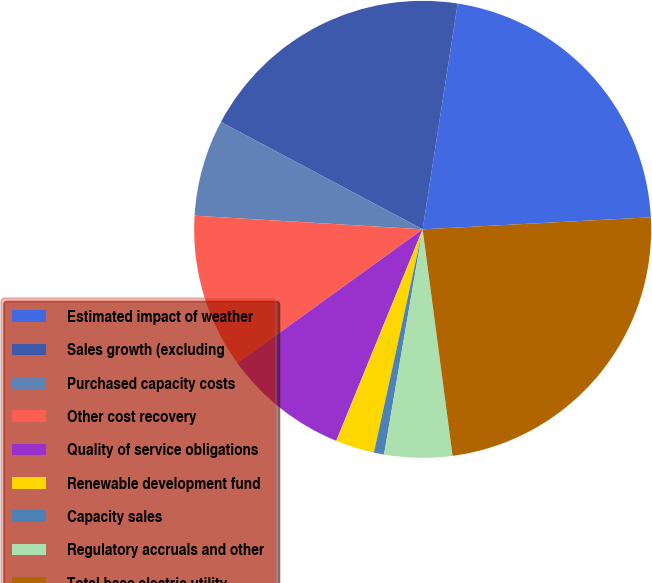<chart> <loc_0><loc_0><loc_500><loc_500><pie_chart><fcel>Estimated impact of weather<fcel>Sales growth (excluding<fcel>Purchased capacity costs<fcel>Other cost recovery<fcel>Quality of service obligations<fcel>Renewable development fund<fcel>Capacity sales<fcel>Regulatory accruals and other<fcel>Total base electric utility<nl><fcel>21.71%<fcel>19.67%<fcel>6.83%<fcel>10.91%<fcel>8.87%<fcel>2.75%<fcel>0.72%<fcel>4.79%<fcel>23.75%<nl></chart> 